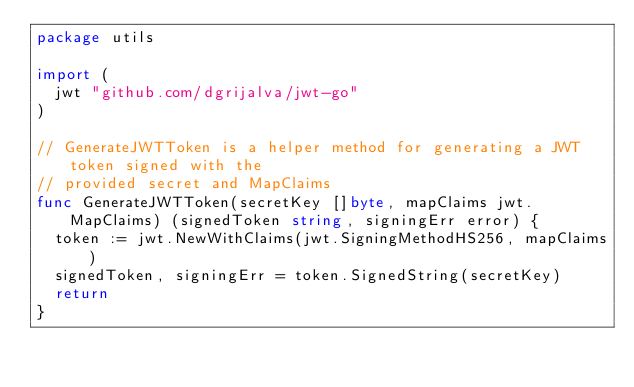<code> <loc_0><loc_0><loc_500><loc_500><_Go_>package utils

import (
	jwt "github.com/dgrijalva/jwt-go"
)

// GenerateJWTToken is a helper method for generating a JWT token signed with the
// provided secret and MapClaims
func GenerateJWTToken(secretKey []byte, mapClaims jwt.MapClaims) (signedToken string, signingErr error) {
	token := jwt.NewWithClaims(jwt.SigningMethodHS256, mapClaims)
	signedToken, signingErr = token.SignedString(secretKey)
	return
}
</code> 